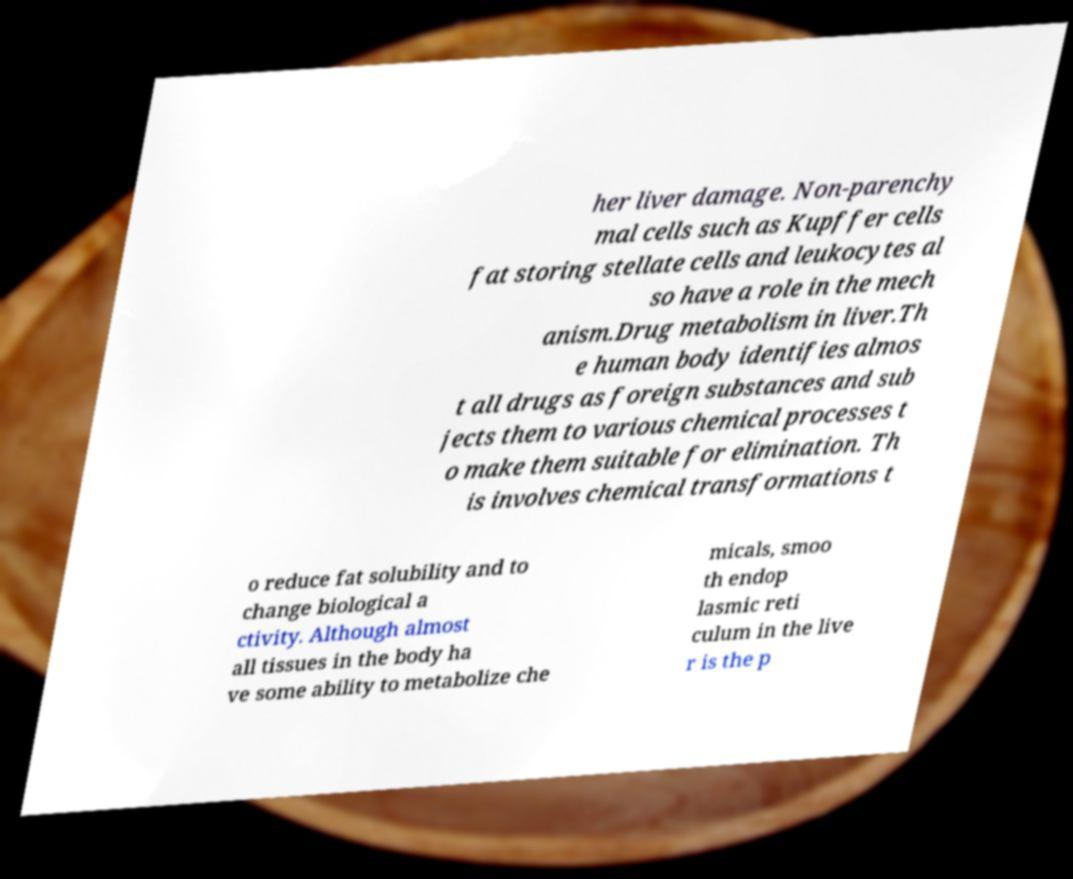Can you read and provide the text displayed in the image?This photo seems to have some interesting text. Can you extract and type it out for me? her liver damage. Non-parenchy mal cells such as Kupffer cells fat storing stellate cells and leukocytes al so have a role in the mech anism.Drug metabolism in liver.Th e human body identifies almos t all drugs as foreign substances and sub jects them to various chemical processes t o make them suitable for elimination. Th is involves chemical transformations t o reduce fat solubility and to change biological a ctivity. Although almost all tissues in the body ha ve some ability to metabolize che micals, smoo th endop lasmic reti culum in the live r is the p 